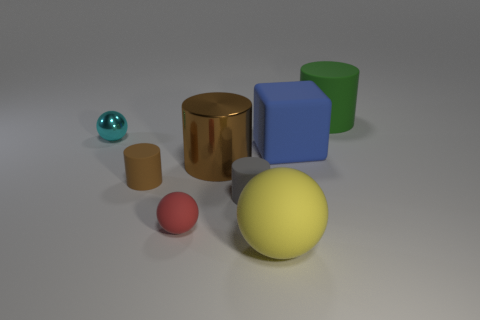Add 2 tiny yellow matte things. How many objects exist? 10 Subtract all green cylinders. How many cylinders are left? 3 Subtract all cyan spheres. How many spheres are left? 2 Subtract all spheres. How many objects are left? 5 Subtract 1 blocks. How many blocks are left? 0 Add 5 shiny cylinders. How many shiny cylinders exist? 6 Subtract 0 purple cylinders. How many objects are left? 8 Subtract all red balls. Subtract all yellow cylinders. How many balls are left? 2 Subtract all cyan spheres. How many yellow cylinders are left? 0 Subtract all brown metal cylinders. Subtract all cyan metal balls. How many objects are left? 6 